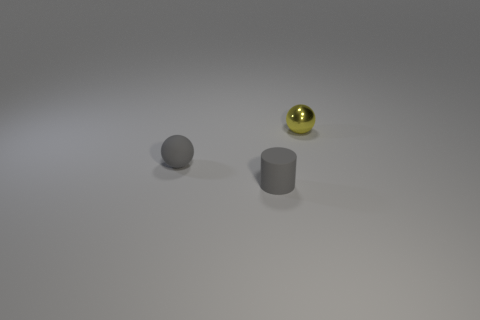Add 3 gray cylinders. How many objects exist? 6 Subtract 0 brown cubes. How many objects are left? 3 Subtract all balls. How many objects are left? 1 Subtract all tiny cylinders. Subtract all shiny objects. How many objects are left? 1 Add 1 yellow metal things. How many yellow metal things are left? 2 Add 3 metallic balls. How many metallic balls exist? 4 